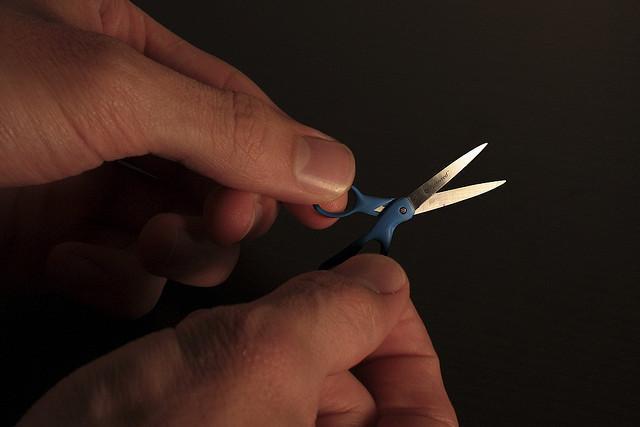How many orange stripes are on the sail?
Give a very brief answer. 0. 